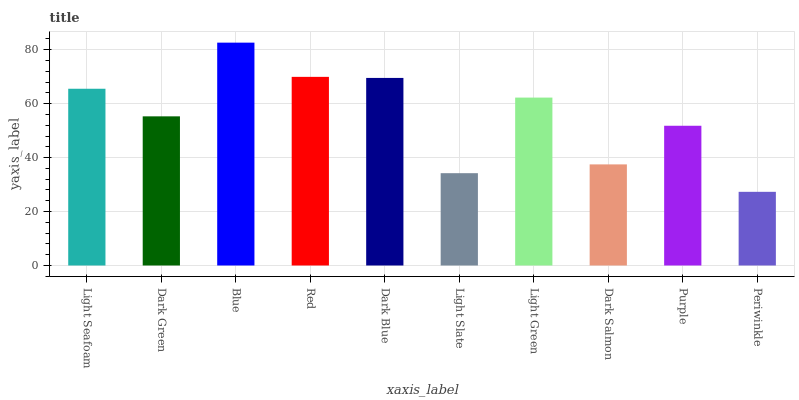Is Periwinkle the minimum?
Answer yes or no. Yes. Is Blue the maximum?
Answer yes or no. Yes. Is Dark Green the minimum?
Answer yes or no. No. Is Dark Green the maximum?
Answer yes or no. No. Is Light Seafoam greater than Dark Green?
Answer yes or no. Yes. Is Dark Green less than Light Seafoam?
Answer yes or no. Yes. Is Dark Green greater than Light Seafoam?
Answer yes or no. No. Is Light Seafoam less than Dark Green?
Answer yes or no. No. Is Light Green the high median?
Answer yes or no. Yes. Is Dark Green the low median?
Answer yes or no. Yes. Is Light Slate the high median?
Answer yes or no. No. Is Red the low median?
Answer yes or no. No. 